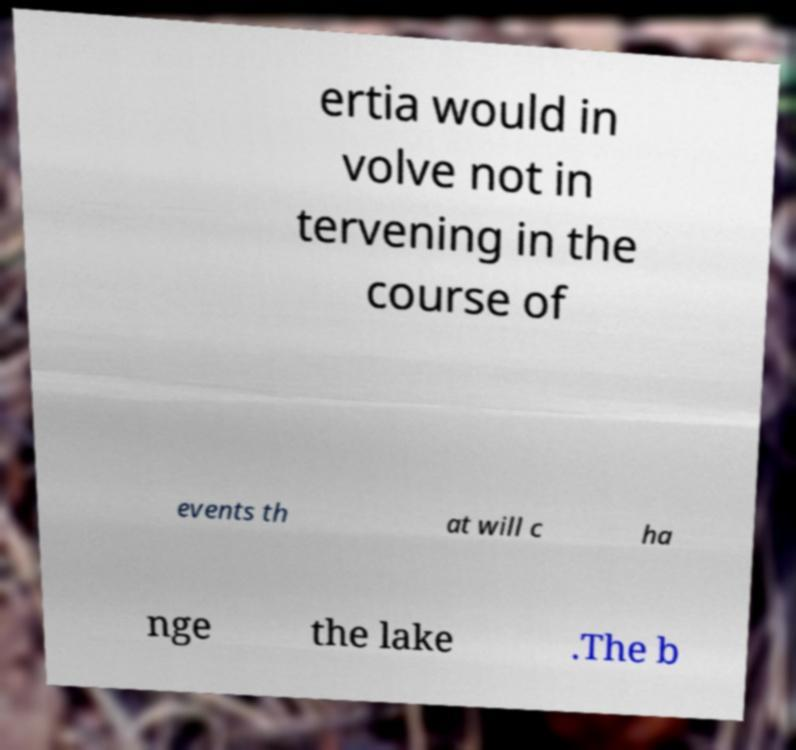Please identify and transcribe the text found in this image. ertia would in volve not in tervening in the course of events th at will c ha nge the lake .The b 